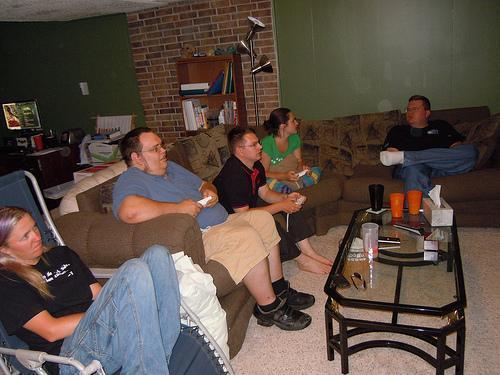How many people in photo?
Give a very brief answer. 5. How many people are wearing blue jeans?
Give a very brief answer. 2. 